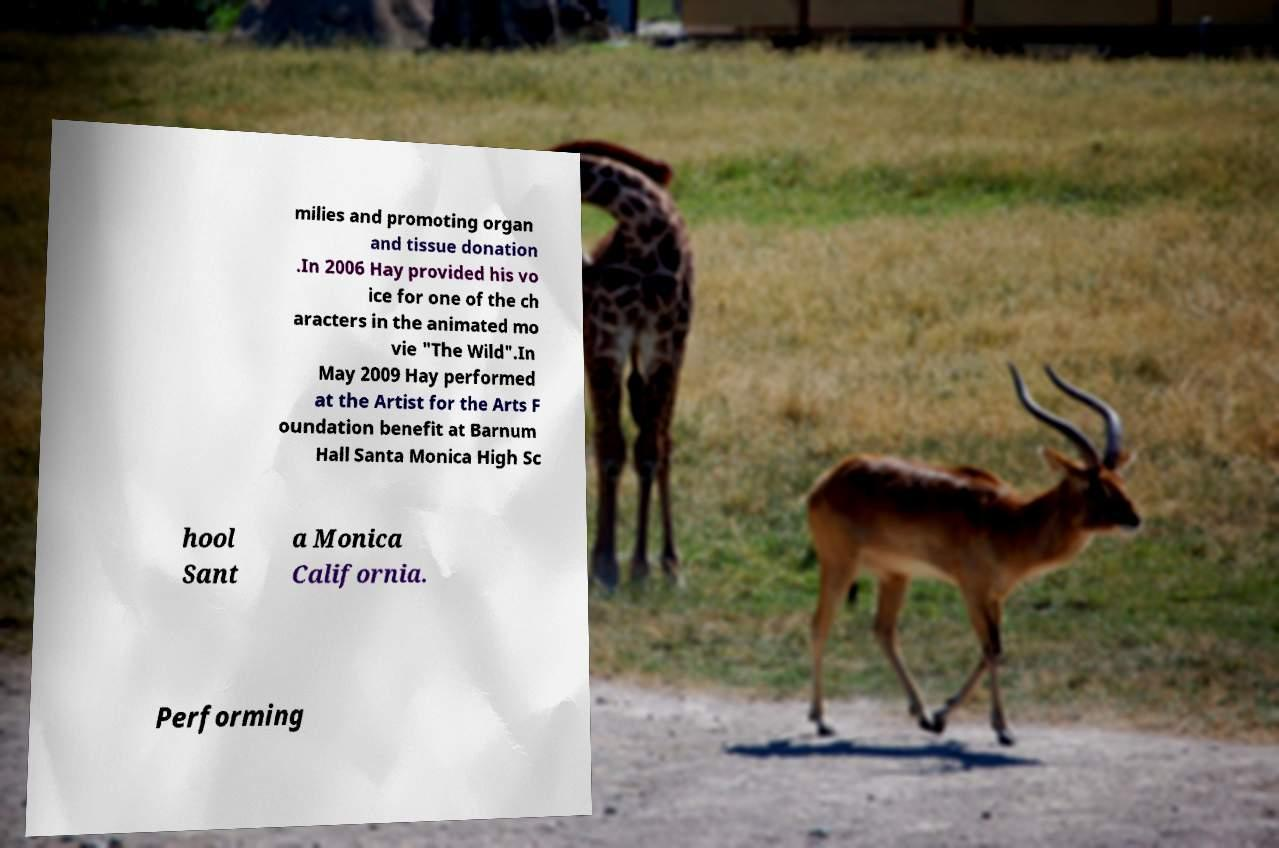There's text embedded in this image that I need extracted. Can you transcribe it verbatim? milies and promoting organ and tissue donation .In 2006 Hay provided his vo ice for one of the ch aracters in the animated mo vie "The Wild".In May 2009 Hay performed at the Artist for the Arts F oundation benefit at Barnum Hall Santa Monica High Sc hool Sant a Monica California. Performing 